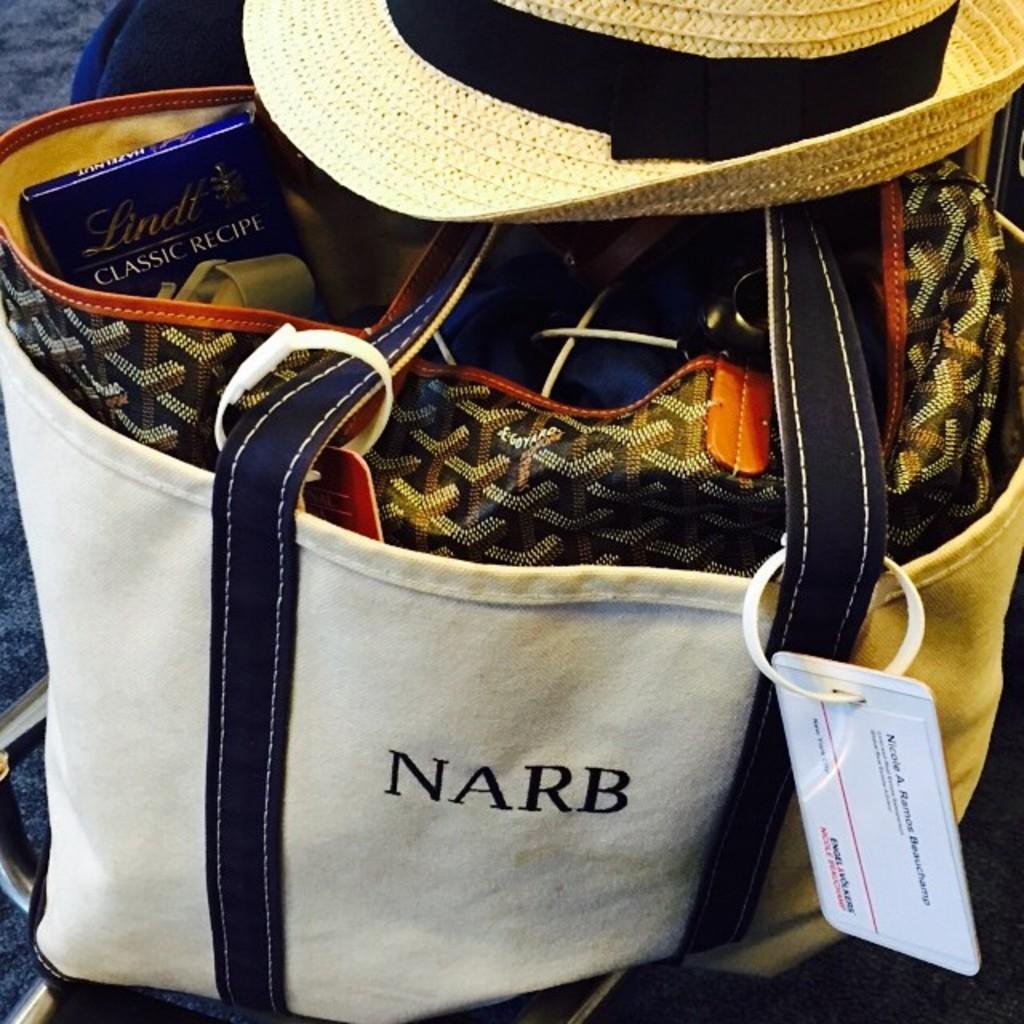How would you summarize this image in a sentence or two? This picture shows a handbag and a hat on it 